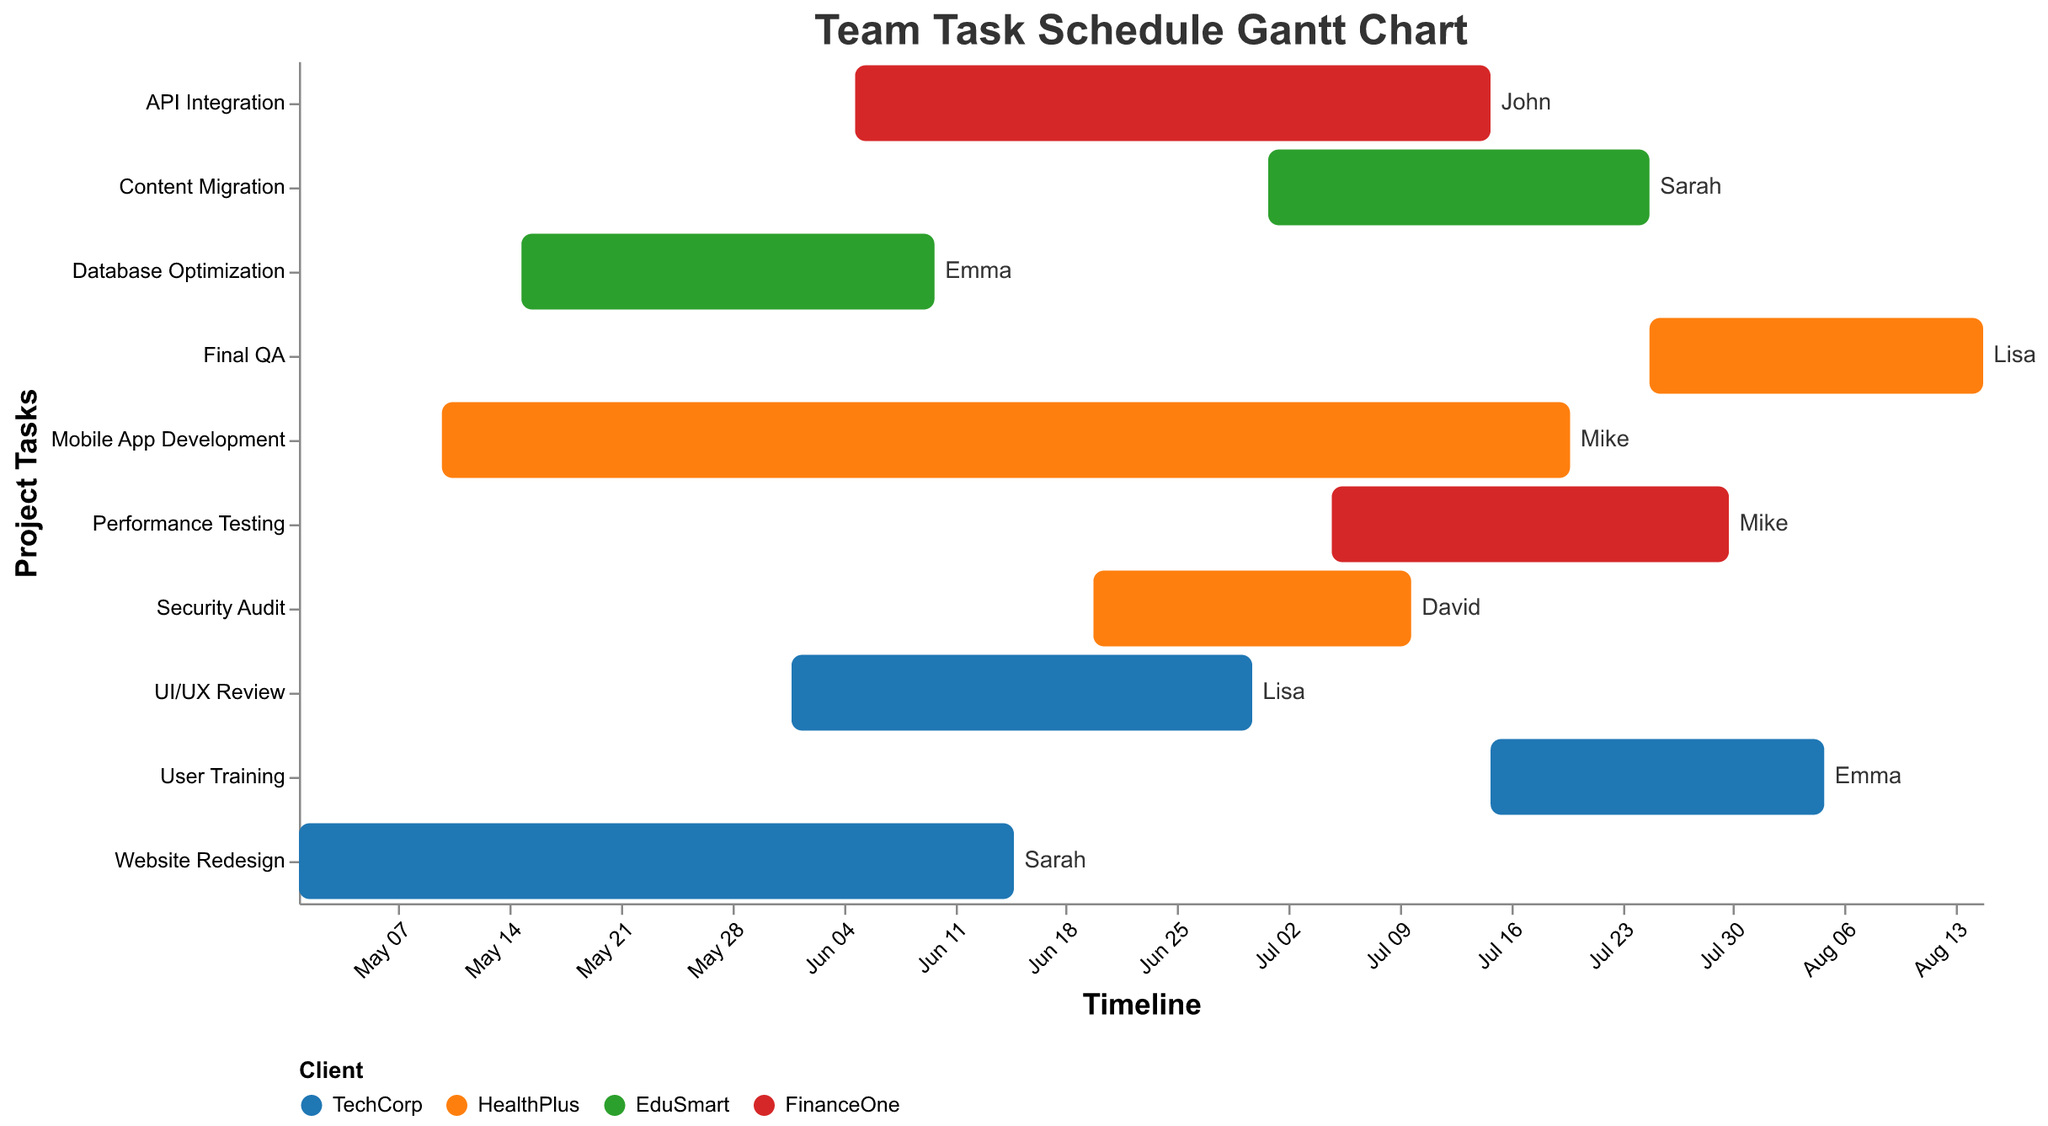Which team member has the most tasks assigned? By looking at the text labels on the bars, we can count the number of tasks assigned to each team member.
Answer: Sarah (2 tasks) Which project finishes the latest? Look at the end dates on the timeline axis and find the task with the furthest end date.
Answer: Final QA How many tasks are assigned to TechCorp? Count the bars colored for TechCorp in the "Client" color legend.
Answer: 3 Which two tasks overlap the longest? Compare the start and end dates of all tasks and identify the pair that has the longest duration of overlap.
Answer: Mobile App Development and API Integration How many tasks are scheduled to start in June? Count the number of bars with a "Start Date" in June.
Answer: 3 Which team member is working on multiple projects for different clients in July? Identify the team members assigned to tasks with overlapping dates in July for different clients.
Answer: Mike What is the duration of the "Website Redesign" task? Calculate the difference between the end date (2023-06-15) and the start date (2023-05-01).
Answer: 45 days Which client has the most tasks running concurrently in July? Identify the client by counting the overlapping tasks in July on the timeline.
Answer: TechCorp Which task has the shortest duration? Compare the duration (end date minus start date) of each task and find the shortest one.
Answer: Database Optimization When does the "User Training" task start, and which team member is responsible for it? Locate the "User Training" task on the y-axis and refer to the "Start Date" and text label.
Answer: 2023-07-15, Emma 